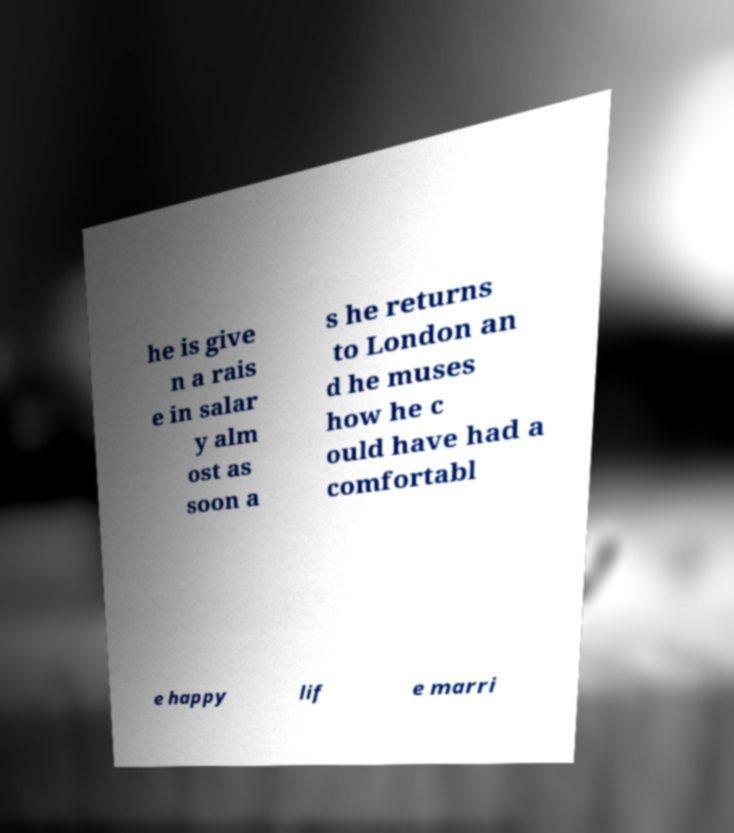Can you read and provide the text displayed in the image?This photo seems to have some interesting text. Can you extract and type it out for me? he is give n a rais e in salar y alm ost as soon a s he returns to London an d he muses how he c ould have had a comfortabl e happy lif e marri 